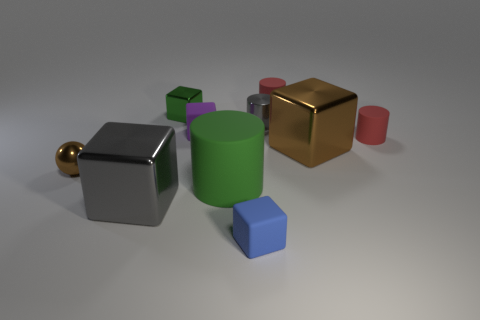What material is the cube that is on the right side of the red rubber cylinder behind the tiny purple block?
Your answer should be compact. Metal. What number of blocks are the same color as the ball?
Offer a very short reply. 1. There is a big green object that is the same material as the purple thing; what shape is it?
Offer a terse response. Cylinder. What is the size of the red rubber object that is in front of the tiny shiny cube?
Make the answer very short. Small. Are there the same number of large metal blocks left of the purple object and small gray cylinders right of the metal cylinder?
Provide a short and direct response. No. What color is the cylinder to the right of the red rubber object behind the tiny red rubber cylinder that is in front of the gray cylinder?
Keep it short and to the point. Red. How many tiny matte blocks are on the right side of the big green object and behind the brown cube?
Make the answer very short. 0. There is a matte cylinder behind the green metallic object; is its color the same as the metal cube that is in front of the big green cylinder?
Make the answer very short. No. Is there any other thing that has the same material as the tiny green thing?
Provide a short and direct response. Yes. The gray object that is the same shape as the blue matte thing is what size?
Give a very brief answer. Large. 